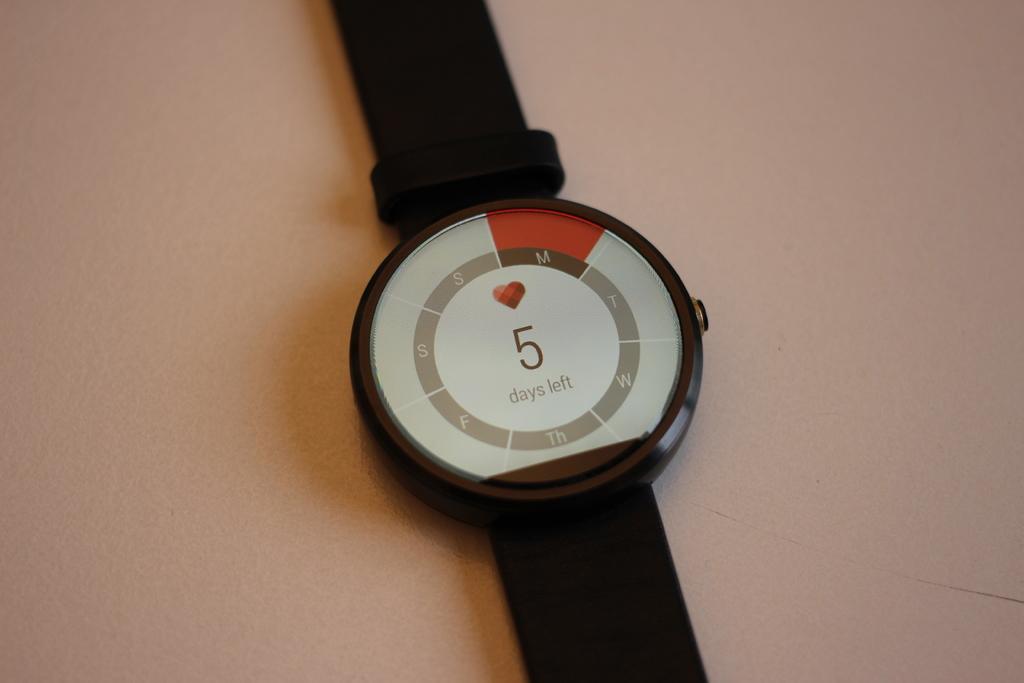How many days left according to the watch?
Keep it short and to the point. 5. What letters are found in the circle?
Your response must be concise. Days left. 